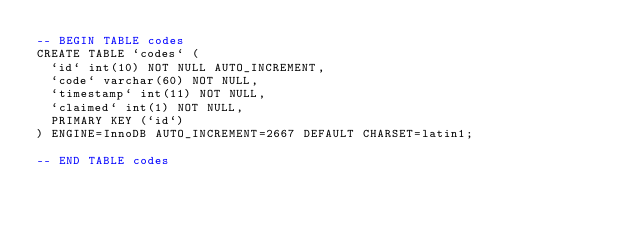<code> <loc_0><loc_0><loc_500><loc_500><_SQL_>-- BEGIN TABLE codes
CREATE TABLE `codes` (
  `id` int(10) NOT NULL AUTO_INCREMENT,
  `code` varchar(60) NOT NULL,
  `timestamp` int(11) NOT NULL,
  `claimed` int(1) NOT NULL,
  PRIMARY KEY (`id`)
) ENGINE=InnoDB AUTO_INCREMENT=2667 DEFAULT CHARSET=latin1;

-- END TABLE codes
</code> 